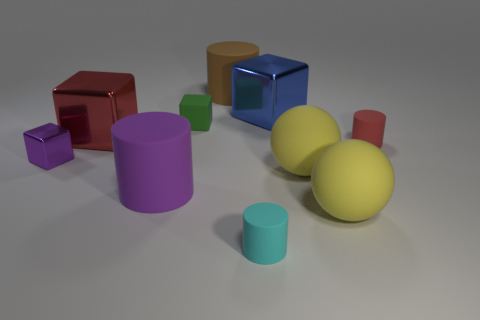Subtract 1 cylinders. How many cylinders are left? 3 Subtract all purple matte cylinders. How many cylinders are left? 3 Subtract all purple cylinders. How many cylinders are left? 3 Subtract all blocks. How many objects are left? 6 Subtract all green cylinders. Subtract all brown balls. How many cylinders are left? 4 Subtract all purple matte cylinders. Subtract all cyan cylinders. How many objects are left? 8 Add 3 big brown cylinders. How many big brown cylinders are left? 4 Add 4 tiny blue matte blocks. How many tiny blue matte blocks exist? 4 Subtract 0 gray cubes. How many objects are left? 10 